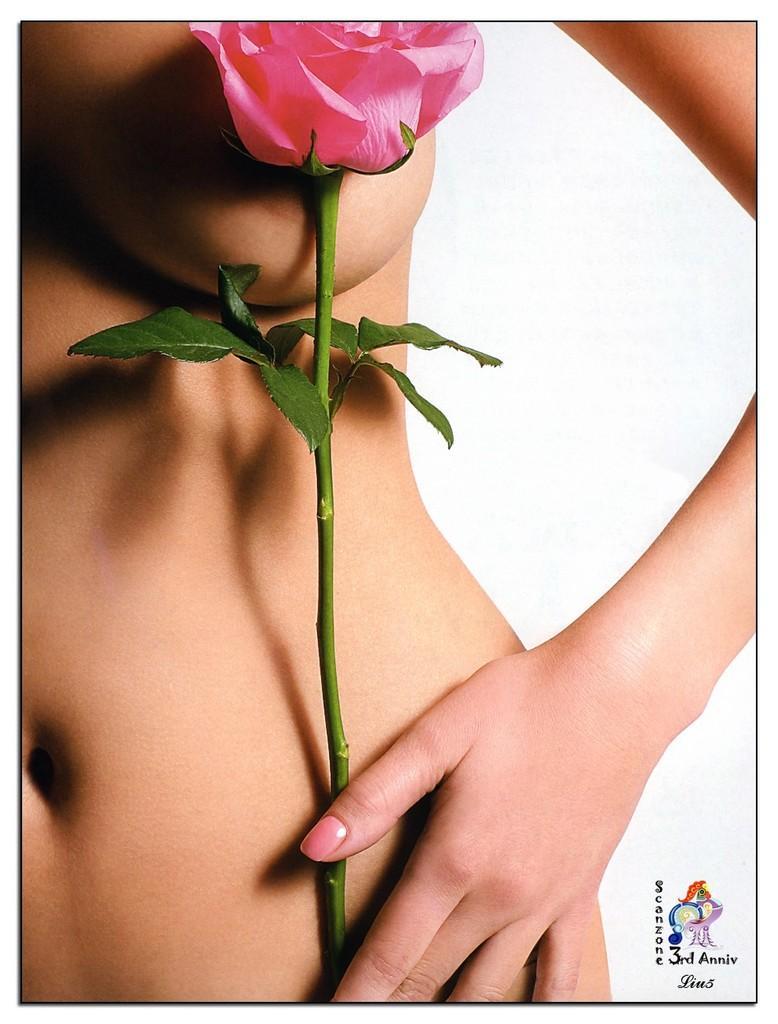Describe this image in one or two sentences. There is a woman in nude holding a plant which is having rose flower and green color leaves. In the bottom left, there is watermark. And the background is white in color. 